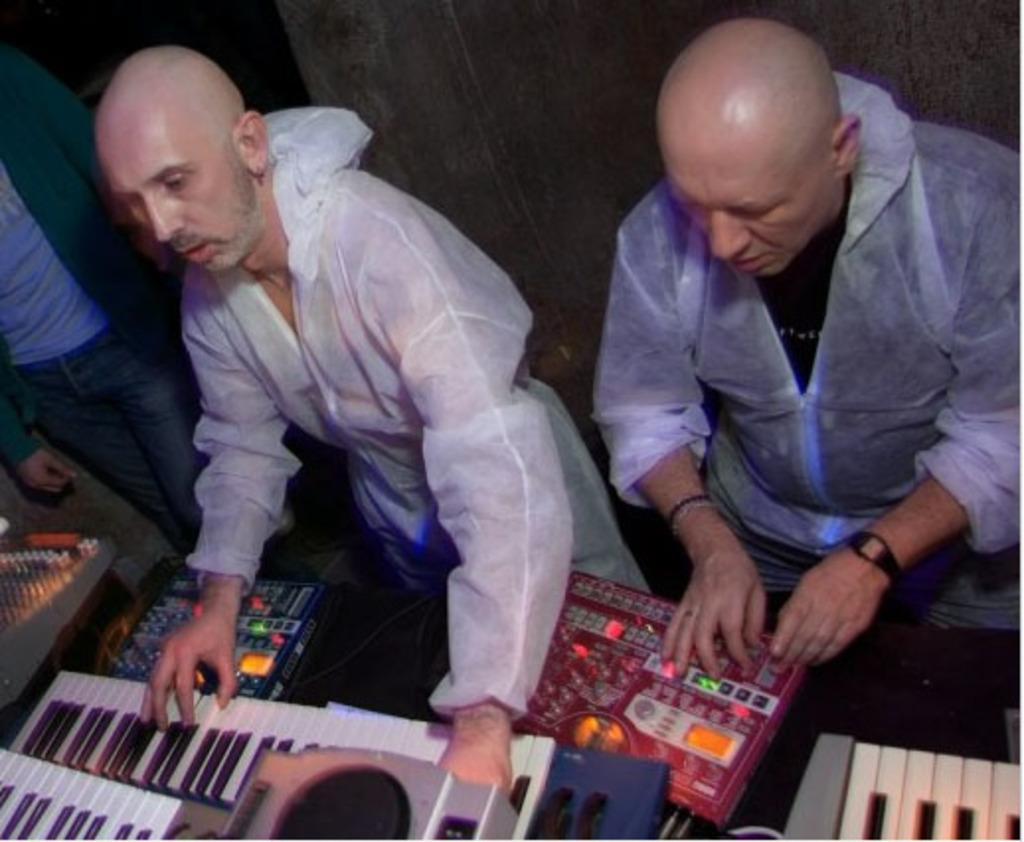Can you describe this image briefly? This picture shows two men seated and a man playing piano and we see other man standing on the side 